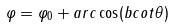Convert formula to latex. <formula><loc_0><loc_0><loc_500><loc_500>\varphi = \varphi _ { 0 } + a r c \cos ( b c o t \theta )</formula> 